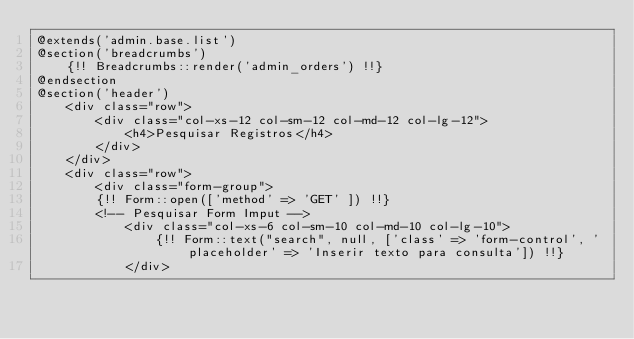<code> <loc_0><loc_0><loc_500><loc_500><_PHP_>@extends('admin.base.list')
@section('breadcrumbs')
    {!! Breadcrumbs::render('admin_orders') !!}
@endsection
@section('header')
    <div class="row">
        <div class="col-xs-12 col-sm-12 col-md-12 col-lg-12">
            <h4>Pesquisar Registros</h4>
        </div>
    </div>
    <div class="row">
        <div class="form-group">
        {!! Form::open(['method' => 'GET' ]) !!}
        <!-- Pesquisar Form Imput -->
            <div class="col-xs-6 col-sm-10 col-md-10 col-lg-10">
                {!! Form::text("search", null, ['class' => 'form-control', 'placeholder' => 'Inserir texto para consulta']) !!}
            </div></code> 